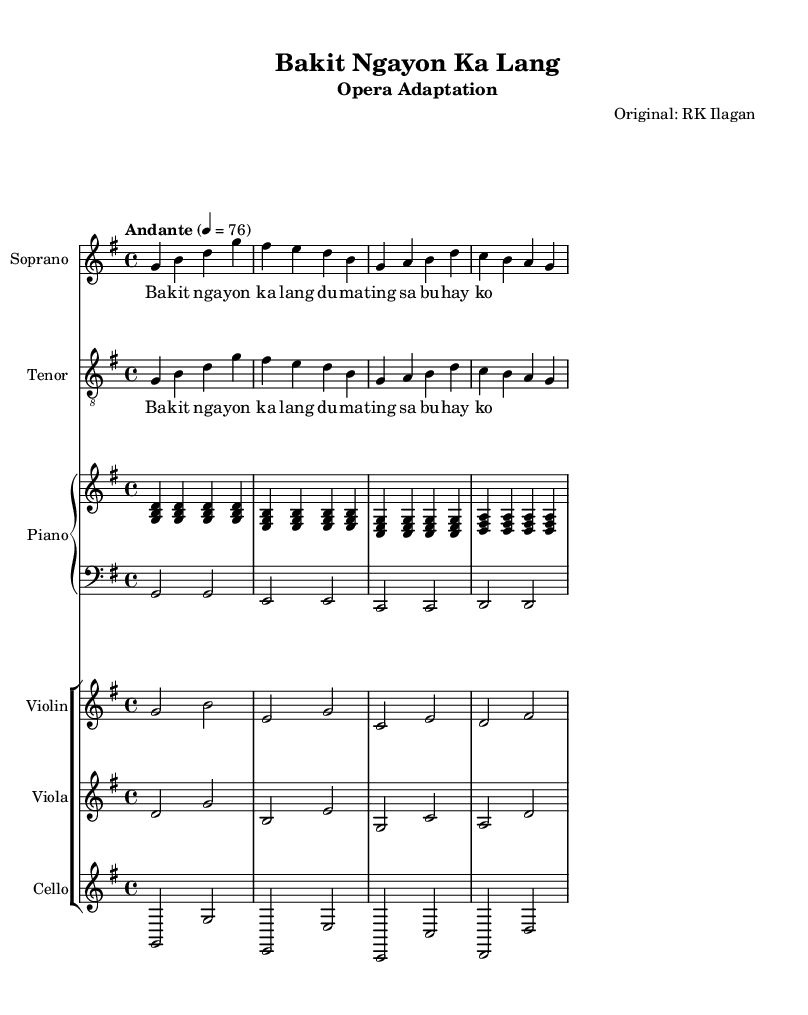What is the key signature of this music? The key signature is G major, which has one sharp (F sharp). It is indicated at the beginning of the staff with a sharp symbol on the F line.
Answer: G major What is the time signature of this piece? The time signature is 4/4, represented as a fraction at the beginning of the piece. This means there are four beats in each measure and the quarter note gets one beat.
Answer: 4/4 What is the tempo marking of this piece? The tempo marking is "Andante," which suggests a moderately slow tempo. This is indicated above the music, setting the pace for the performance.
Answer: Andante How many measures are there in the soprano part? The soprano part contains four measures, as each group of notes is separated by vertical lines indicating the end of each measure.
Answer: 4 What instruments are featured in this opera adaptation? The featured instruments are Soprano, Tenor, Piano, Violin, Viola, and Cello. This is indicated by the instrument names at the beginning of their respective staves.
Answer: Soprano, Tenor, Piano, Violin, Viola, Cello What type of vocal parts are included in the music? The vocal parts included are Soprano and Tenor, which are indicated by the labels on their respective staves. Each part has its own distinct line for the melody.
Answer: Soprano and Tenor What is the lyric text associated with the first measure of the Soprano part? The lyric text associated with the first measure of the Soprano part is "Bakit nga yon ka lang." This is shown below the notes in the Soprano staff, aligning with the melody.
Answer: Bakit nga yon ka lang 